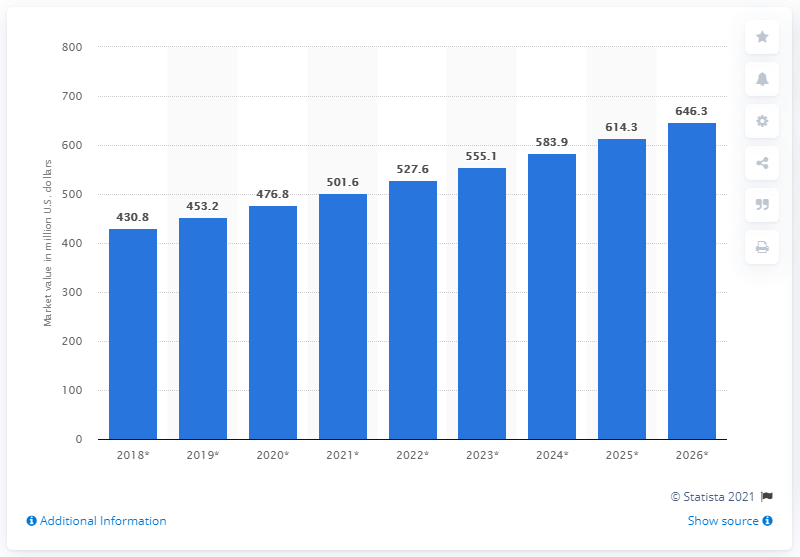Draw attention to some important aspects in this diagram. According to the data from 2018, the global avocado oil market was valued at approximately 430.8 million dollars in that year. The global avocado oil market is projected to reach a value of 646.3 million USD by 2026. 